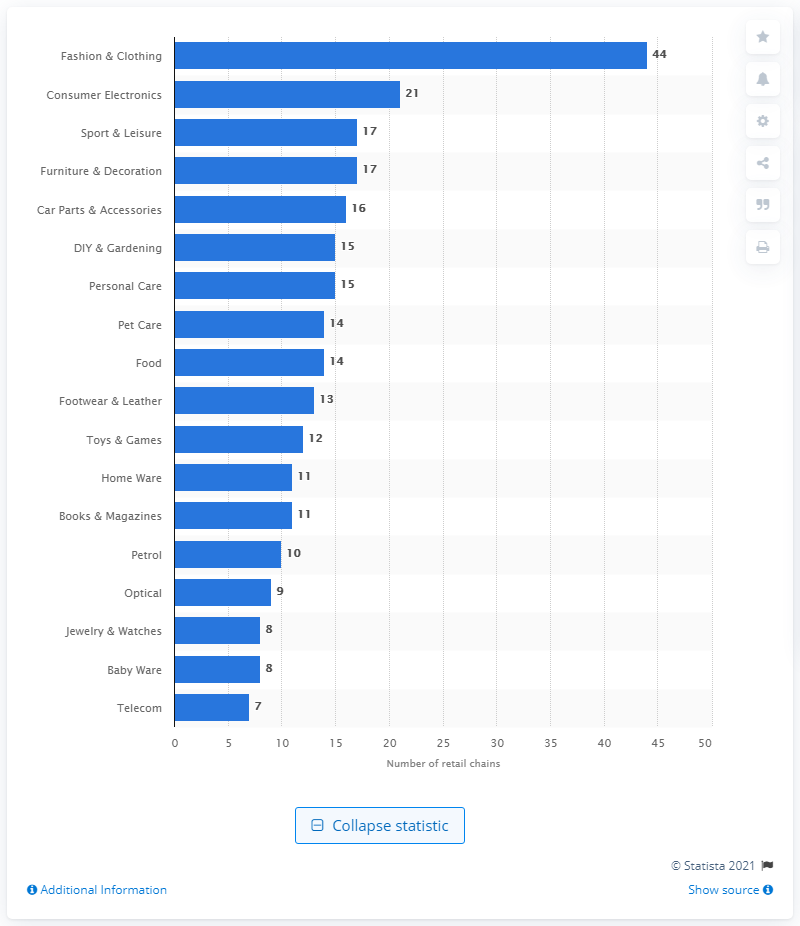List a handful of essential elements in this visual. In the year 2020, there were 21 retail chains operating in Austria. 